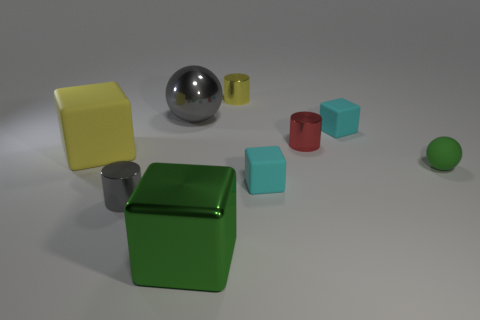There is a small ball; is it the same color as the small metallic cylinder that is on the left side of the shiny cube?
Offer a very short reply. No. What is the size of the yellow thing that is left of the small metal cylinder left of the big green cube that is in front of the small rubber ball?
Ensure brevity in your answer.  Large. How many other tiny blocks have the same color as the metal cube?
Provide a succinct answer. 0. What number of things are either big spheres or metal cylinders in front of the yellow metallic cylinder?
Your answer should be very brief. 3. The metal cube has what color?
Your answer should be very brief. Green. There is a block on the left side of the shiny cube; what is its color?
Give a very brief answer. Yellow. What number of tiny gray cylinders are right of the small cyan cube in front of the yellow block?
Provide a short and direct response. 0. Do the gray cylinder and the sphere right of the large gray sphere have the same size?
Keep it short and to the point. Yes. Are there any red matte spheres of the same size as the gray metallic cylinder?
Keep it short and to the point. No. How many objects are gray metallic cylinders or yellow rubber cubes?
Provide a succinct answer. 2. 